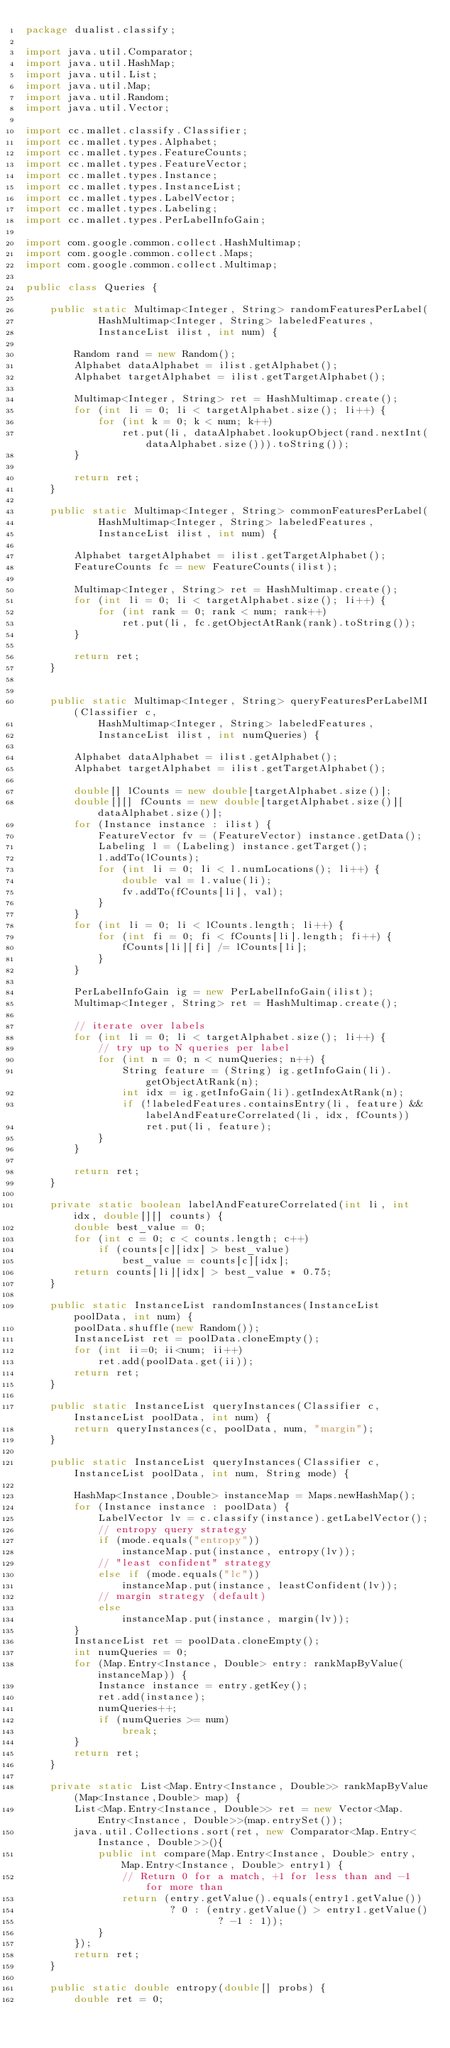<code> <loc_0><loc_0><loc_500><loc_500><_Java_>package dualist.classify;

import java.util.Comparator;
import java.util.HashMap;
import java.util.List;
import java.util.Map;
import java.util.Random;
import java.util.Vector;

import cc.mallet.classify.Classifier;
import cc.mallet.types.Alphabet;
import cc.mallet.types.FeatureCounts;
import cc.mallet.types.FeatureVector;
import cc.mallet.types.Instance;
import cc.mallet.types.InstanceList;
import cc.mallet.types.LabelVector;
import cc.mallet.types.Labeling;
import cc.mallet.types.PerLabelInfoGain;

import com.google.common.collect.HashMultimap;
import com.google.common.collect.Maps;
import com.google.common.collect.Multimap;

public class Queries {

    public static Multimap<Integer, String> randomFeaturesPerLabel(
            HashMultimap<Integer, String> labeledFeatures,
            InstanceList ilist, int num) {

        Random rand = new Random();
        Alphabet dataAlphabet = ilist.getAlphabet();
        Alphabet targetAlphabet = ilist.getTargetAlphabet();

        Multimap<Integer, String> ret = HashMultimap.create();
        for (int li = 0; li < targetAlphabet.size(); li++) {
            for (int k = 0; k < num; k++)
                ret.put(li, dataAlphabet.lookupObject(rand.nextInt(dataAlphabet.size())).toString());
        }

        return ret;
    }

    public static Multimap<Integer, String> commonFeaturesPerLabel(
            HashMultimap<Integer, String> labeledFeatures,
            InstanceList ilist, int num) {

        Alphabet targetAlphabet = ilist.getTargetAlphabet();
        FeatureCounts fc = new FeatureCounts(ilist); 

        Multimap<Integer, String> ret = HashMultimap.create();
        for (int li = 0; li < targetAlphabet.size(); li++) {
            for (int rank = 0; rank < num; rank++)
                ret.put(li, fc.getObjectAtRank(rank).toString());
        }

        return ret;
    }


    public static Multimap<Integer, String> queryFeaturesPerLabelMI(Classifier c, 
            HashMultimap<Integer, String> labeledFeatures, 
            InstanceList ilist, int numQueries) {

        Alphabet dataAlphabet = ilist.getAlphabet();
        Alphabet targetAlphabet = ilist.getTargetAlphabet();

        double[] lCounts = new double[targetAlphabet.size()];
        double[][] fCounts = new double[targetAlphabet.size()][dataAlphabet.size()];
        for (Instance instance : ilist) {
            FeatureVector fv = (FeatureVector) instance.getData();
            Labeling l = (Labeling) instance.getTarget();
            l.addTo(lCounts);
            for (int li = 0; li < l.numLocations(); li++) {
                double val = l.value(li);
                fv.addTo(fCounts[li], val);
            }
        }
        for (int li = 0; li < lCounts.length; li++) {
            for (int fi = 0; fi < fCounts[li].length; fi++) {
                fCounts[li][fi] /= lCounts[li];
            }
        }

        PerLabelInfoGain ig = new PerLabelInfoGain(ilist);
        Multimap<Integer, String> ret = HashMultimap.create();

        // iterate over labels
        for (int li = 0; li < targetAlphabet.size(); li++) {
            // try up to N queries per label
            for (int n = 0; n < numQueries; n++) {
                String feature = (String) ig.getInfoGain(li).getObjectAtRank(n);
                int idx = ig.getInfoGain(li).getIndexAtRank(n);
                if (!labeledFeatures.containsEntry(li, feature) && labelAndFeatureCorrelated(li, idx, fCounts))
                    ret.put(li, feature);
            }
        }

        return ret;
    }

    private static boolean labelAndFeatureCorrelated(int li, int idx, double[][] counts) {
        double best_value = 0;		
        for (int c = 0; c < counts.length; c++)
            if (counts[c][idx] > best_value)
                best_value = counts[c][idx]; 
        return counts[li][idx] > best_value * 0.75;
    }

    public static InstanceList randomInstances(InstanceList poolData, int num) {
        poolData.shuffle(new Random());
        InstanceList ret = poolData.cloneEmpty();
        for (int ii=0; ii<num; ii++)
            ret.add(poolData.get(ii));
        return ret;
    }

    public static InstanceList queryInstances(Classifier c, InstanceList poolData, int num) {
        return queryInstances(c, poolData, num, "margin");
    }

    public static InstanceList queryInstances(Classifier c, InstanceList poolData, int num, String mode) {

        HashMap<Instance,Double> instanceMap = Maps.newHashMap();
        for (Instance instance : poolData) {
            LabelVector lv = c.classify(instance).getLabelVector();
            // entropy query strategy
            if (mode.equals("entropy"))
                instanceMap.put(instance, entropy(lv));
            // "least confident" strategy
            else if (mode.equals("lc"))
                instanceMap.put(instance, leastConfident(lv));
            // margin strategy (default)
            else
                instanceMap.put(instance, margin(lv));
        }
        InstanceList ret = poolData.cloneEmpty();
        int numQueries = 0;
        for (Map.Entry<Instance, Double> entry: rankMapByValue(instanceMap)) {
            Instance instance = entry.getKey();
            ret.add(instance);
            numQueries++;
            if (numQueries >= num)
                break;
        }
        return ret;
    }

    private static List<Map.Entry<Instance, Double>> rankMapByValue(Map<Instance,Double> map) {
        List<Map.Entry<Instance, Double>> ret = new Vector<Map.Entry<Instance, Double>>(map.entrySet());
        java.util.Collections.sort(ret, new Comparator<Map.Entry<Instance, Double>>(){
            public int compare(Map.Entry<Instance, Double> entry, Map.Entry<Instance, Double> entry1) {
                // Return 0 for a match, +1 for less than and -1 for more than
                return (entry.getValue().equals(entry1.getValue()) 
                        ? 0 : (entry.getValue() > entry1.getValue() 
                                ? -1 : 1));
            }
        });
        return ret;
    }

    public static double entropy(double[] probs) {
        double ret = 0;</code> 